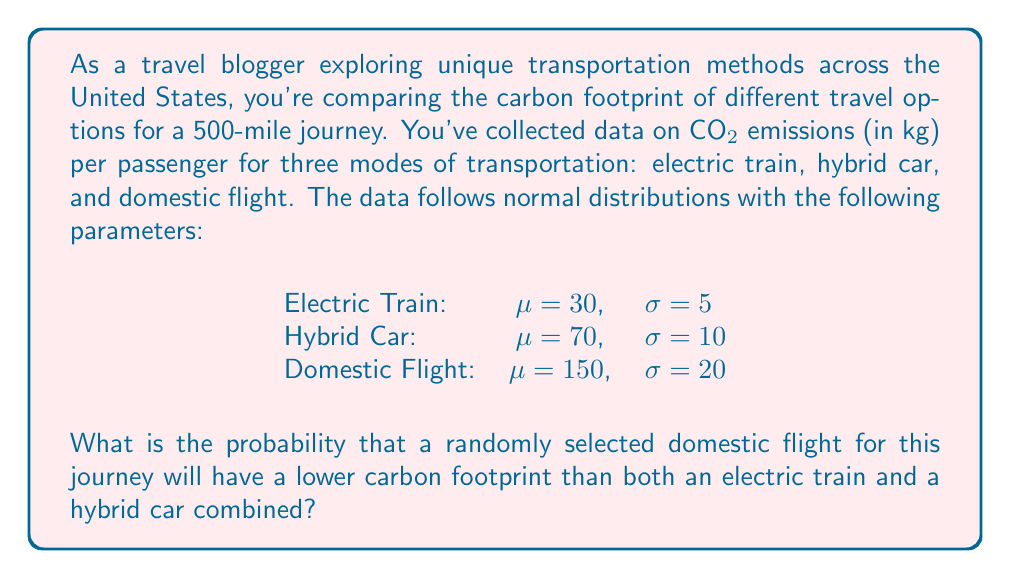Help me with this question. To solve this problem, we need to follow these steps:

1. Find the mean and standard deviation of the combined carbon footprint of the electric train and hybrid car.
2. Calculate the z-score for the point where the domestic flight's emissions equal the combined emissions of the other two modes.
3. Use the standard normal distribution to find the probability.

Step 1: Combined carbon footprint of electric train and hybrid car
Mean: $\mu_{\text{combined}} = \mu_{\text{train}} + \mu_{\text{car}} = 30 + 70 = 100$ kg
Variance: $\sigma^2_{\text{combined}} = \sigma^2_{\text{train}} + \sigma^2_{\text{car}} = 5^2 + 10^2 = 125$
Standard deviation: $\sigma_{\text{combined}} = \sqrt{125} \approx 11.18$ kg

Step 2: Calculate the z-score
Z-score formula: $z = \frac{x - \mu}{\sigma}$

For the domestic flight to have lower emissions than the combined other modes:
$x = 100$ (the point where flight emissions equal combined emissions)
$\mu = 150$ (mean of flight emissions)
$\sigma = 20$ (standard deviation of flight emissions)

$z = \frac{100 - 150}{20} = -2.5$

Step 3: Find the probability using the standard normal distribution
The probability we're looking for is the area to the left of z = -2.5 on the standard normal distribution curve.

Using a standard normal distribution table or calculator:
$P(Z < -2.5) \approx 0.0062$

This means there's approximately a 0.62% chance that a randomly selected domestic flight will have lower emissions than the combined electric train and hybrid car for this 500-mile journey.
Answer: 0.0062 or 0.62% 